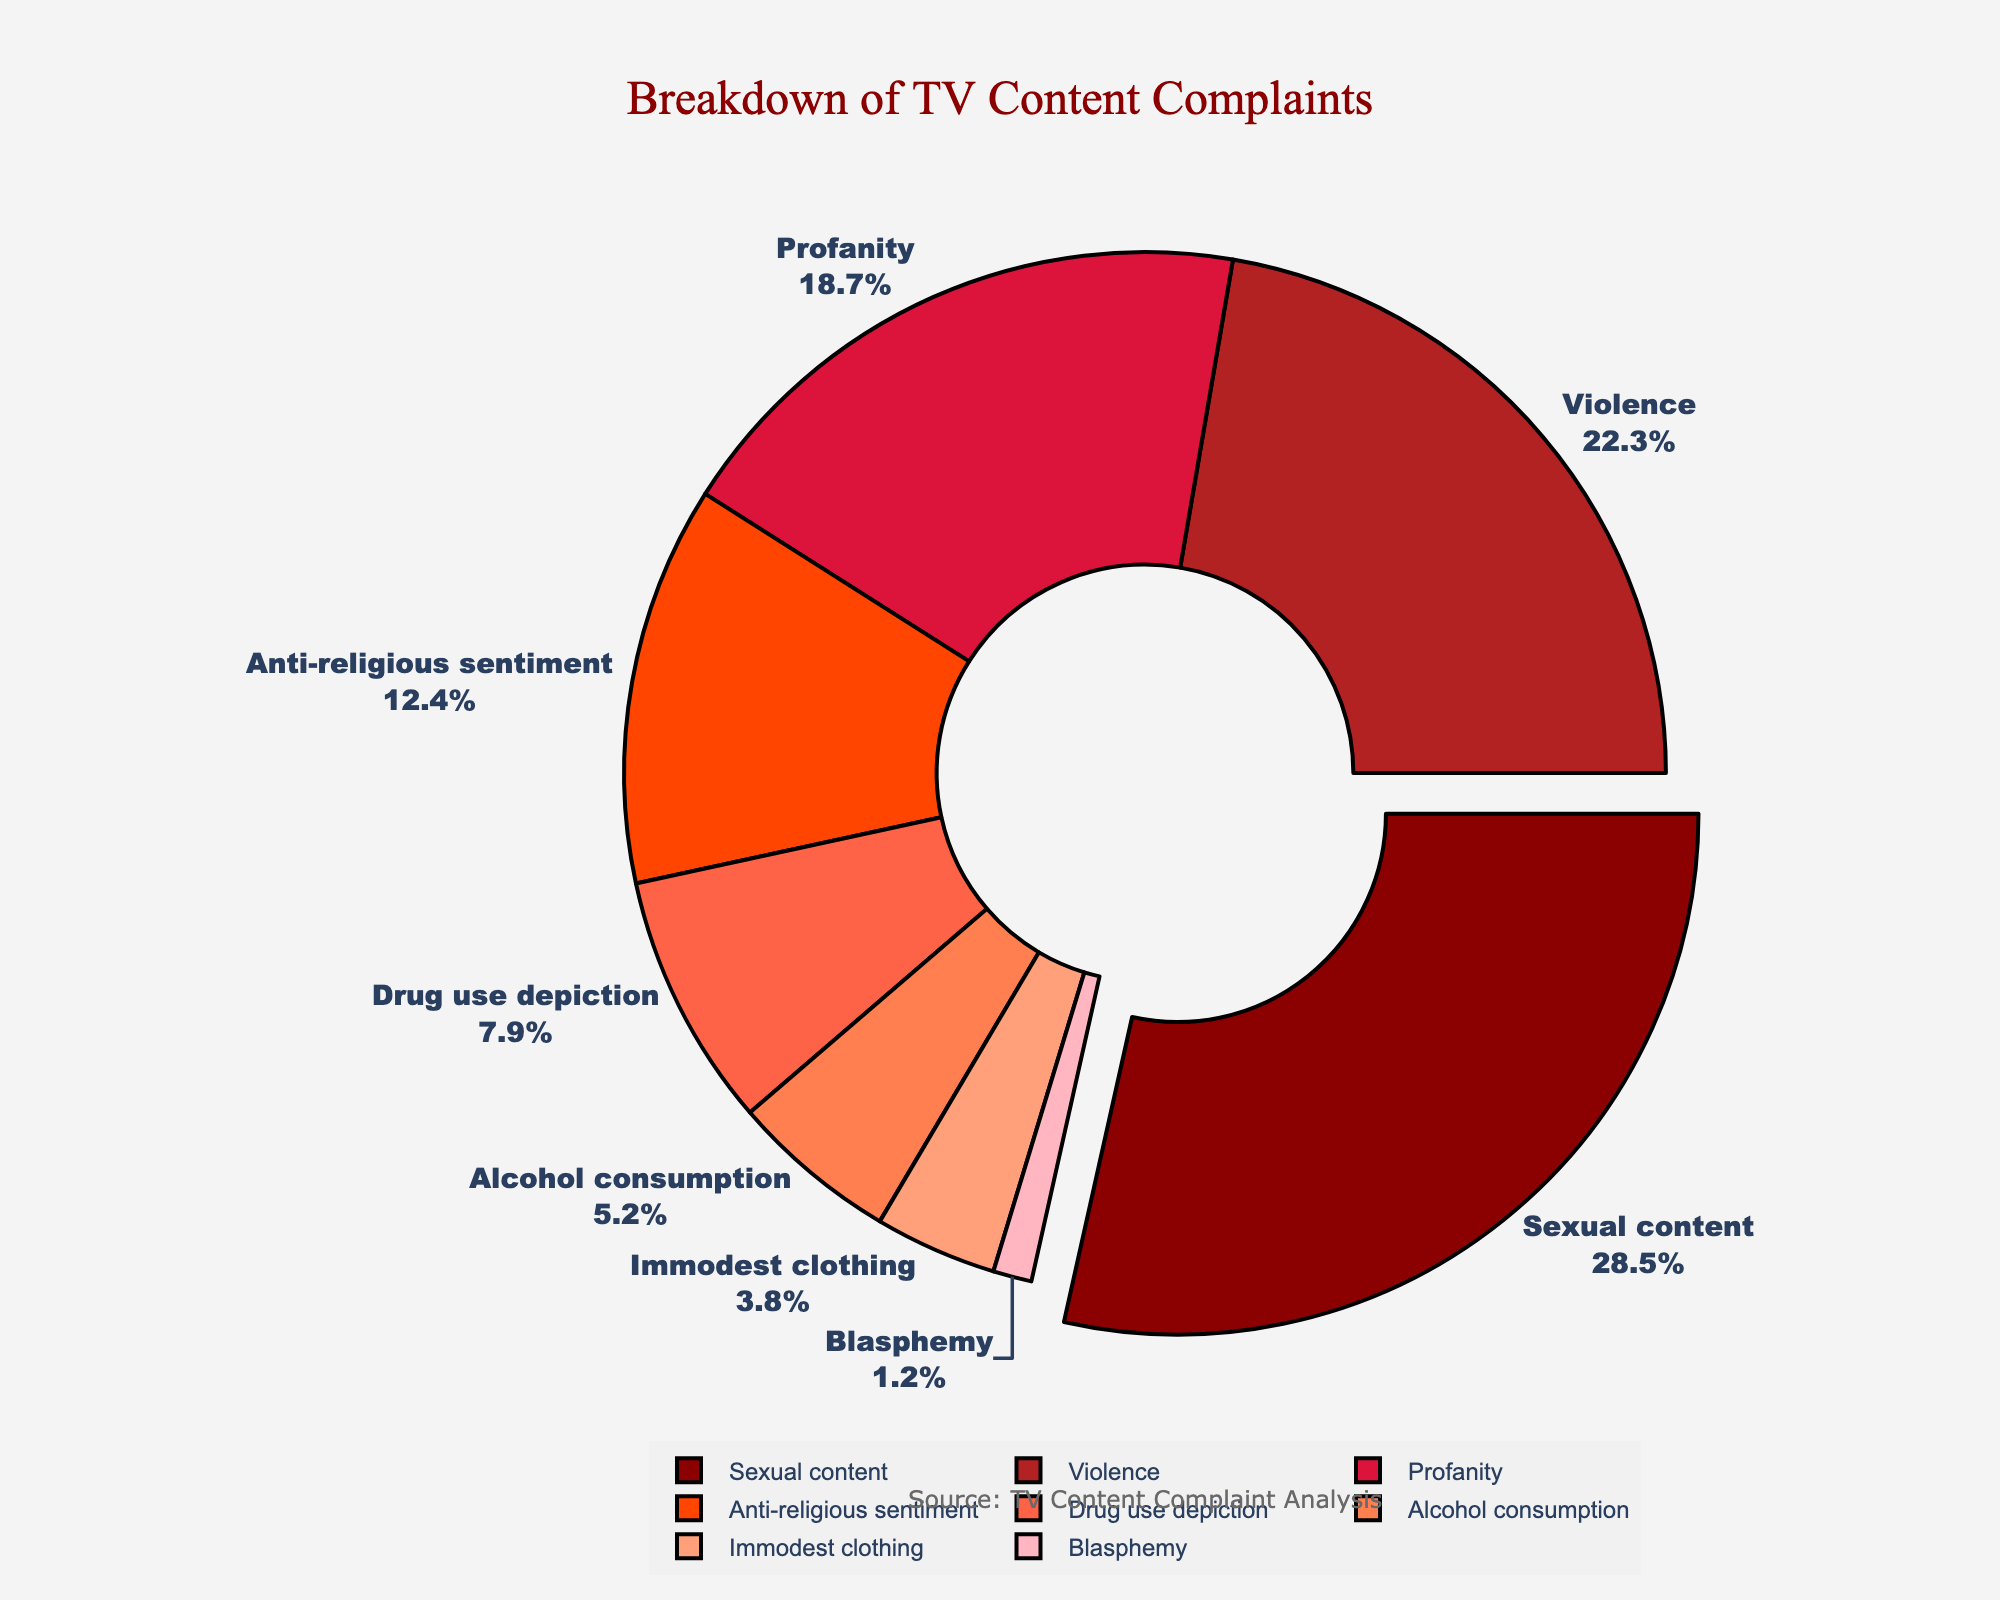What type of offensive material has the highest percentage? The fig legend shows various types of offensive material percentages. By looking at the largest section of the pie chart, we find that "Sexual content" occupies the largest part.
Answer: Sexual content Which two types of offensive material combined make up more than half of the complains? From the pie chart, we see that "Sexual content" is 28.5% and "Violence" is 22.3%. Adding these, 28.5 + 22.3 = 50.8, which is more than half.
Answer: Sexual content and Violence How does the percentage of complaints about Profanity compare to Anti-religious sentiment? Looking at the percentages from the chart, Profanity is 18.7% and Anti-religious sentiment is 12.4%. 18.7 is greater than 12.4.
Answer: Profanity is higher What is the sum of the percentages of Drug use depiction and Alcohol consumption? From the legend, Drug use depiction is 7.9% and Alcohol consumption is 5.2%. Adding these: 7.9 + 5.2 = 13.1%.
Answer: 13.1% Which complaint category is represented by the smallest section of the pie chart? By referring to the smallest section in the pie chart, we can see that "Blasphemy" occupies the smallest segment.
Answer: Blasphemy How much larger is the percentage of complaints about Violence compared to that of Immodest clothing? From the chart, Violence is 22.3% and Immodest clothing is 3.8%. Subtracting these: 22.3 - 3.8 = 18.5%.
Answer: 18.5% Which type of offensive material has less than 10% of the complaints but more than 5%? The chart shows that Drug use depiction is 7.9% and Alcohol consumption is 5.2%. Both percentages meet these criteria.
Answer: Drug use depiction and Alcohol consumption Calculate the average percentage of complaints for categories related to substance depiction (Drug use depiction and Alcohol consumption). Adding Drug use depiction (7.9%) and Alcohol consumption (5.2%), we get 7.9 + 5.2 = 13.1. Dividing by 2: 13.1/2 = 6.55%.
Answer: 6.55% Compare the sum of the percentages for Profanity and Anti-religious sentiment with 30%. Is it greater or less? Profanity is 18.7% and Anti-religious sentiment is 12.4%. Adding them: 18.7 + 12.4 = 31.1%. Comparing to 30: 31.1 is greater than 30.
Answer: Greater Identify the color used to represent the category with the highest percentage. The pie chart color spectrum shows that the largest section (Sexual content) is in red.
Answer: Red 